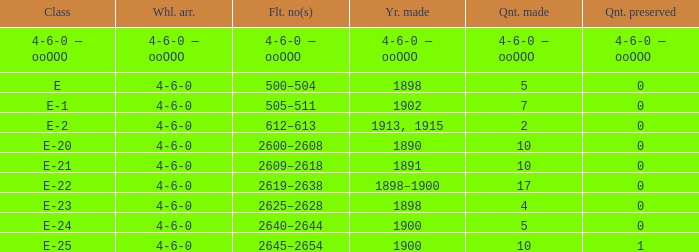What is the wheel arrangement made in 1890? 4-6-0. 